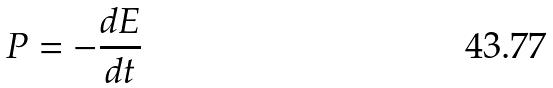Convert formula to latex. <formula><loc_0><loc_0><loc_500><loc_500>P = - \frac { d E } { d t }</formula> 